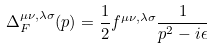Convert formula to latex. <formula><loc_0><loc_0><loc_500><loc_500>\Delta _ { F } ^ { \mu \nu , \lambda \sigma } ( p ) = \frac { 1 } { 2 } f ^ { \mu \nu , \lambda \sigma } \frac { 1 } { p ^ { 2 } - i \epsilon }</formula> 